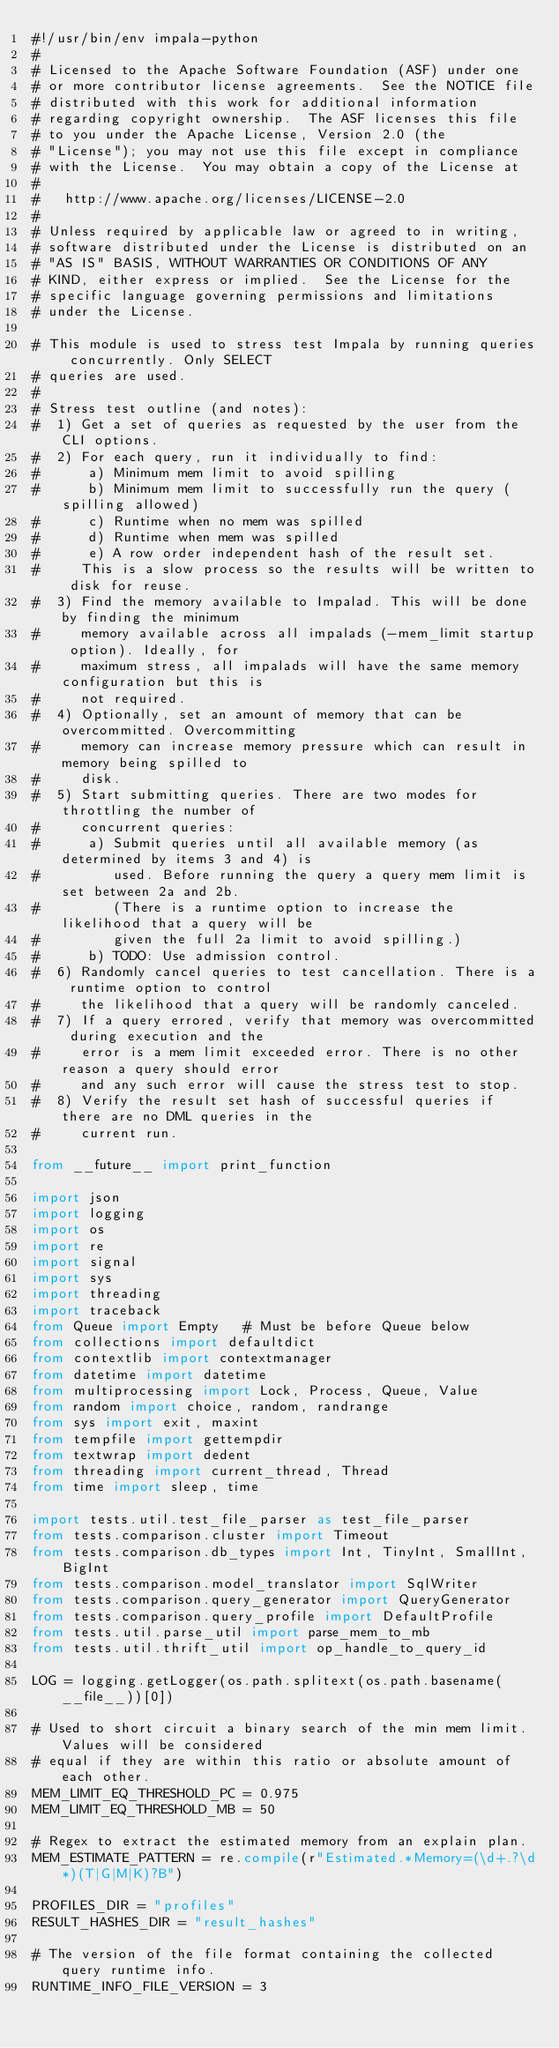Convert code to text. <code><loc_0><loc_0><loc_500><loc_500><_Python_>#!/usr/bin/env impala-python
#
# Licensed to the Apache Software Foundation (ASF) under one
# or more contributor license agreements.  See the NOTICE file
# distributed with this work for additional information
# regarding copyright ownership.  The ASF licenses this file
# to you under the Apache License, Version 2.0 (the
# "License"); you may not use this file except in compliance
# with the License.  You may obtain a copy of the License at
#
#   http://www.apache.org/licenses/LICENSE-2.0
#
# Unless required by applicable law or agreed to in writing,
# software distributed under the License is distributed on an
# "AS IS" BASIS, WITHOUT WARRANTIES OR CONDITIONS OF ANY
# KIND, either express or implied.  See the License for the
# specific language governing permissions and limitations
# under the License.

# This module is used to stress test Impala by running queries concurrently. Only SELECT
# queries are used.
#
# Stress test outline (and notes):
#  1) Get a set of queries as requested by the user from the CLI options.
#  2) For each query, run it individually to find:
#      a) Minimum mem limit to avoid spilling
#      b) Minimum mem limit to successfully run the query (spilling allowed)
#      c) Runtime when no mem was spilled
#      d) Runtime when mem was spilled
#      e) A row order independent hash of the result set.
#     This is a slow process so the results will be written to disk for reuse.
#  3) Find the memory available to Impalad. This will be done by finding the minimum
#     memory available across all impalads (-mem_limit startup option). Ideally, for
#     maximum stress, all impalads will have the same memory configuration but this is
#     not required.
#  4) Optionally, set an amount of memory that can be overcommitted. Overcommitting
#     memory can increase memory pressure which can result in memory being spilled to
#     disk.
#  5) Start submitting queries. There are two modes for throttling the number of
#     concurrent queries:
#      a) Submit queries until all available memory (as determined by items 3 and 4) is
#         used. Before running the query a query mem limit is set between 2a and 2b.
#         (There is a runtime option to increase the likelihood that a query will be
#         given the full 2a limit to avoid spilling.)
#      b) TODO: Use admission control.
#  6) Randomly cancel queries to test cancellation. There is a runtime option to control
#     the likelihood that a query will be randomly canceled.
#  7) If a query errored, verify that memory was overcommitted during execution and the
#     error is a mem limit exceeded error. There is no other reason a query should error
#     and any such error will cause the stress test to stop.
#  8) Verify the result set hash of successful queries if there are no DML queries in the
#     current run.

from __future__ import print_function

import json
import logging
import os
import re
import signal
import sys
import threading
import traceback
from Queue import Empty   # Must be before Queue below
from collections import defaultdict
from contextlib import contextmanager
from datetime import datetime
from multiprocessing import Lock, Process, Queue, Value
from random import choice, random, randrange
from sys import exit, maxint
from tempfile import gettempdir
from textwrap import dedent
from threading import current_thread, Thread
from time import sleep, time

import tests.util.test_file_parser as test_file_parser
from tests.comparison.cluster import Timeout
from tests.comparison.db_types import Int, TinyInt, SmallInt, BigInt
from tests.comparison.model_translator import SqlWriter
from tests.comparison.query_generator import QueryGenerator
from tests.comparison.query_profile import DefaultProfile
from tests.util.parse_util import parse_mem_to_mb
from tests.util.thrift_util import op_handle_to_query_id

LOG = logging.getLogger(os.path.splitext(os.path.basename(__file__))[0])

# Used to short circuit a binary search of the min mem limit. Values will be considered
# equal if they are within this ratio or absolute amount of each other.
MEM_LIMIT_EQ_THRESHOLD_PC = 0.975
MEM_LIMIT_EQ_THRESHOLD_MB = 50

# Regex to extract the estimated memory from an explain plan.
MEM_ESTIMATE_PATTERN = re.compile(r"Estimated.*Memory=(\d+.?\d*)(T|G|M|K)?B")

PROFILES_DIR = "profiles"
RESULT_HASHES_DIR = "result_hashes"

# The version of the file format containing the collected query runtime info.
RUNTIME_INFO_FILE_VERSION = 3

</code> 